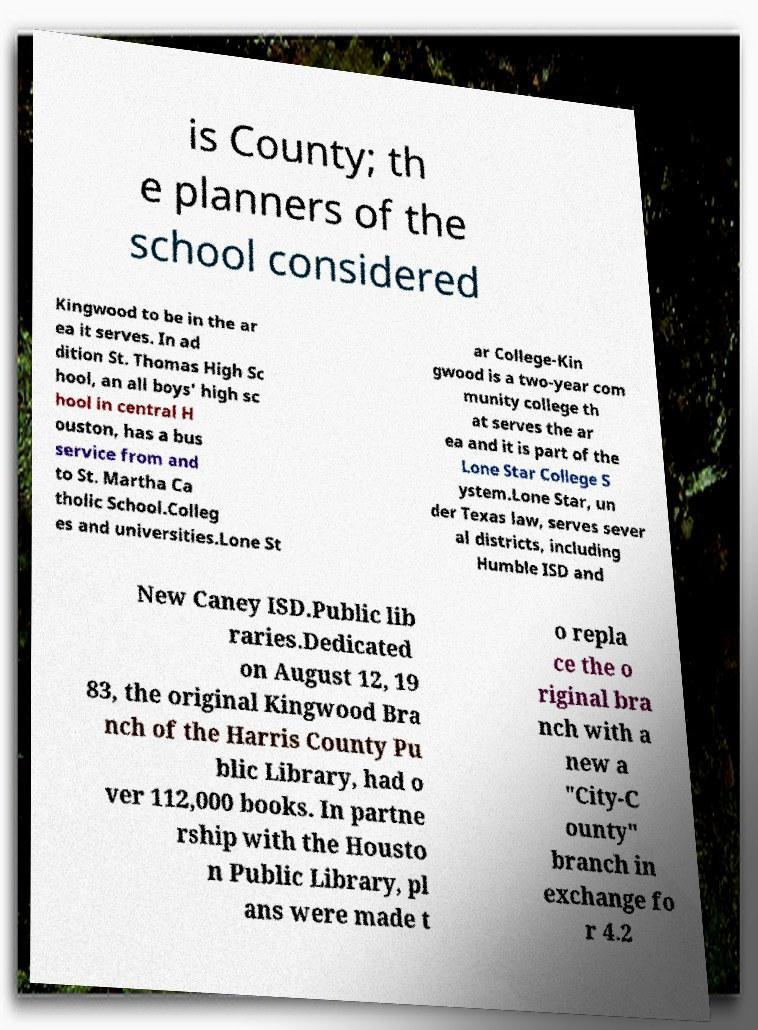Could you extract and type out the text from this image? is County; th e planners of the school considered Kingwood to be in the ar ea it serves. In ad dition St. Thomas High Sc hool, an all boys' high sc hool in central H ouston, has a bus service from and to St. Martha Ca tholic School.Colleg es and universities.Lone St ar College-Kin gwood is a two-year com munity college th at serves the ar ea and it is part of the Lone Star College S ystem.Lone Star, un der Texas law, serves sever al districts, including Humble ISD and New Caney ISD.Public lib raries.Dedicated on August 12, 19 83, the original Kingwood Bra nch of the Harris County Pu blic Library, had o ver 112,000 books. In partne rship with the Housto n Public Library, pl ans were made t o repla ce the o riginal bra nch with a new a "City-C ounty" branch in exchange fo r 4.2 